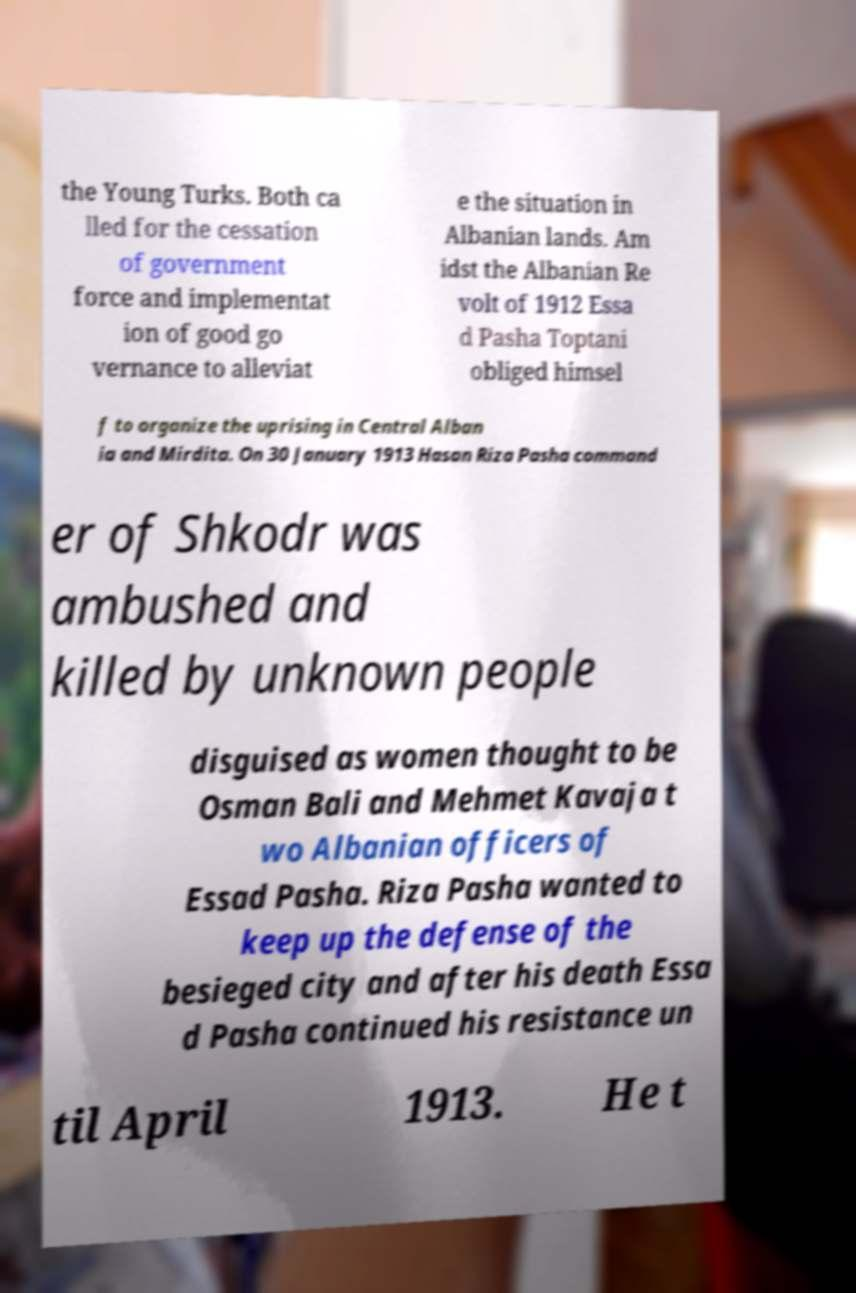Can you read and provide the text displayed in the image?This photo seems to have some interesting text. Can you extract and type it out for me? the Young Turks. Both ca lled for the cessation of government force and implementat ion of good go vernance to alleviat e the situation in Albanian lands. Am idst the Albanian Re volt of 1912 Essa d Pasha Toptani obliged himsel f to organize the uprising in Central Alban ia and Mirdita. On 30 January 1913 Hasan Riza Pasha command er of Shkodr was ambushed and killed by unknown people disguised as women thought to be Osman Bali and Mehmet Kavaja t wo Albanian officers of Essad Pasha. Riza Pasha wanted to keep up the defense of the besieged city and after his death Essa d Pasha continued his resistance un til April 1913. He t 